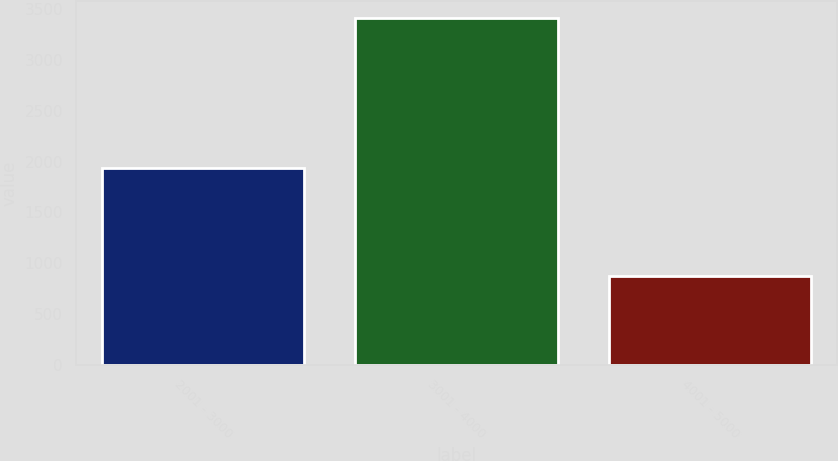Convert chart to OTSL. <chart><loc_0><loc_0><loc_500><loc_500><bar_chart><fcel>2001 - 3000<fcel>3001 - 4000<fcel>4001 - 5000<nl><fcel>1938<fcel>3408<fcel>879<nl></chart> 